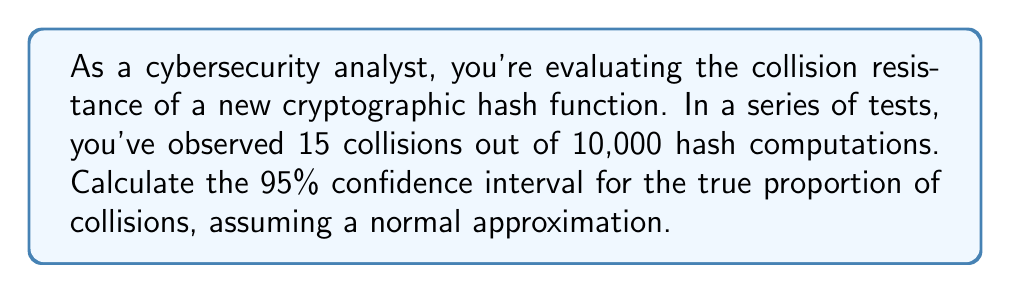Give your solution to this math problem. Let's approach this step-by-step:

1) First, we need to calculate the sample proportion:
   $\hat{p} = \frac{\text{number of collisions}}{\text{total hash computations}} = \frac{15}{10000} = 0.0015$

2) The formula for the confidence interval is:
   $$\hat{p} \pm z_{\alpha/2} \sqrt{\frac{\hat{p}(1-\hat{p})}{n}}$$
   where $z_{\alpha/2}$ is the critical value for the desired confidence level, and $n$ is the sample size.

3) For a 95% confidence interval, $z_{\alpha/2} = 1.96$

4) Plugging in our values:
   $$0.0015 \pm 1.96 \sqrt{\frac{0.0015(1-0.0015)}{10000}}$$

5) Simplify under the square root:
   $$0.0015 \pm 1.96 \sqrt{\frac{0.0014977}{10000}} = 0.0015 \pm 1.96 \sqrt{0.00000014977}$$

6) Calculate:
   $$0.0015 \pm 1.96 (0.0003869) = 0.0015 \pm 0.0007583$$

7) Therefore, the confidence interval is:
   $$(0.0015 - 0.0007583, 0.0015 + 0.0007583) = (0.0007417, 0.0022583)$$
Answer: (0.0007417, 0.0022583) 